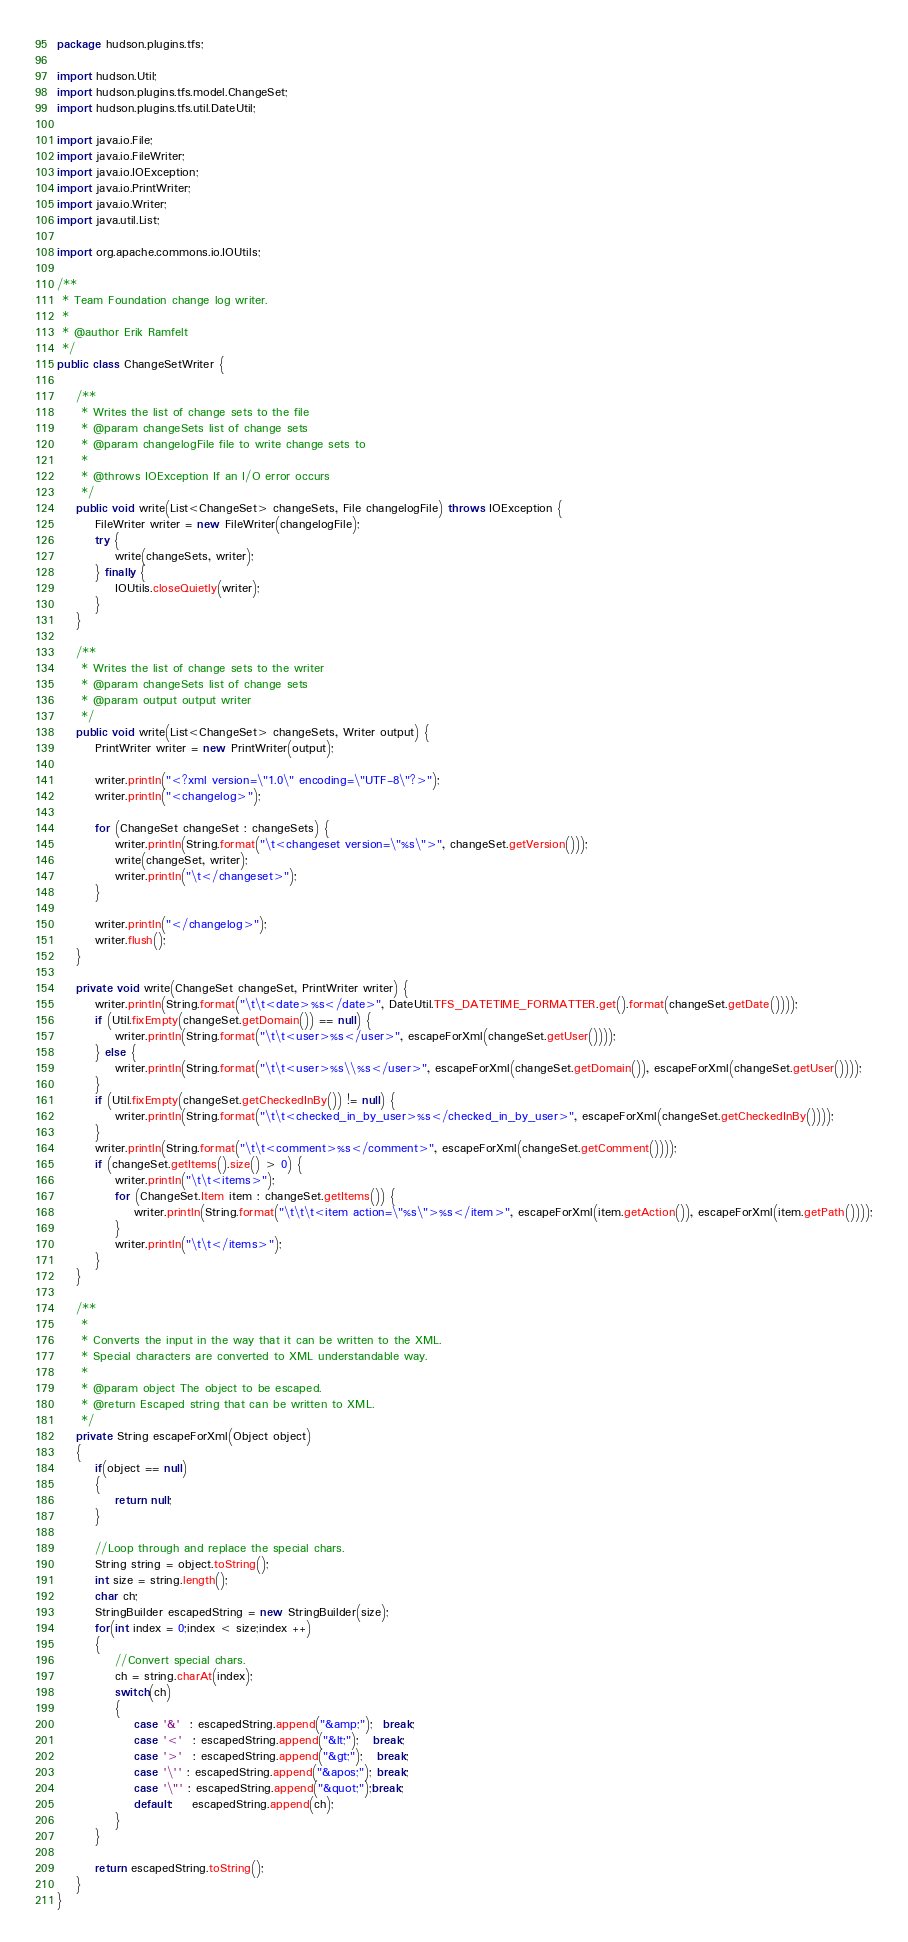Convert code to text. <code><loc_0><loc_0><loc_500><loc_500><_Java_>package hudson.plugins.tfs;

import hudson.Util;
import hudson.plugins.tfs.model.ChangeSet;
import hudson.plugins.tfs.util.DateUtil;

import java.io.File;
import java.io.FileWriter;
import java.io.IOException;
import java.io.PrintWriter;
import java.io.Writer;
import java.util.List;

import org.apache.commons.io.IOUtils;

/**
 * Team Foundation change log writer.
 * 
 * @author Erik Ramfelt
 */
public class ChangeSetWriter {

    /**
     * Writes the list of change sets to the file
     * @param changeSets list of change sets
     * @param changelogFile file to write change sets to
     *
     * @throws IOException If an I/O error occurs
     */
    public void write(List<ChangeSet> changeSets, File changelogFile) throws IOException {
        FileWriter writer = new FileWriter(changelogFile);
        try {
            write(changeSets, writer);
        } finally {
            IOUtils.closeQuietly(writer);
        }
    }

    /**
     * Writes the list of change sets to the writer
     * @param changeSets list of change sets
     * @param output output writer
     */    
    public void write(List<ChangeSet> changeSets, Writer output) {
        PrintWriter writer = new PrintWriter(output);
        
        writer.println("<?xml version=\"1.0\" encoding=\"UTF-8\"?>");
        writer.println("<changelog>");
        
        for (ChangeSet changeSet : changeSets) {
            writer.println(String.format("\t<changeset version=\"%s\">", changeSet.getVersion()));
            write(changeSet, writer);
            writer.println("\t</changeset>");
        }
        
        writer.println("</changelog>");
        writer.flush();
    }

    private void write(ChangeSet changeSet, PrintWriter writer) {
        writer.println(String.format("\t\t<date>%s</date>", DateUtil.TFS_DATETIME_FORMATTER.get().format(changeSet.getDate())));
        if (Util.fixEmpty(changeSet.getDomain()) == null) {
            writer.println(String.format("\t\t<user>%s</user>", escapeForXml(changeSet.getUser())));
        } else {
            writer.println(String.format("\t\t<user>%s\\%s</user>", escapeForXml(changeSet.getDomain()), escapeForXml(changeSet.getUser())));
        }
        if (Util.fixEmpty(changeSet.getCheckedInBy()) != null) {
            writer.println(String.format("\t\t<checked_in_by_user>%s</checked_in_by_user>", escapeForXml(changeSet.getCheckedInBy())));
        }
        writer.println(String.format("\t\t<comment>%s</comment>", escapeForXml(changeSet.getComment())));
        if (changeSet.getItems().size() > 0) {
            writer.println("\t\t<items>");
            for (ChangeSet.Item item : changeSet.getItems()) {
                writer.println(String.format("\t\t\t<item action=\"%s\">%s</item>", escapeForXml(item.getAction()), escapeForXml(item.getPath())));
            }
            writer.println("\t\t</items>");
        }
    }

    /**
     * 
     * Converts the input in the way that it can be written to the XML.
     * Special characters are converted to XML understandable way.
     * 
     * @param object The object to be escaped.
     * @return Escaped string that can be written to XML.
     */
    private String escapeForXml(Object object)
    {
        if(object == null)
        {
            return null;
        }

        //Loop through and replace the special chars.
        String string = object.toString();
        int size = string.length();
        char ch;
        StringBuilder escapedString = new StringBuilder(size);
        for(int index = 0;index < size;index ++)
        {
            //Convert special chars.
            ch = string.charAt(index);
            switch(ch)
            {
                case '&'  : escapedString.append("&amp;");  break;
                case '<'  : escapedString.append("&lt;");   break;
                case '>'  : escapedString.append("&gt;");   break;
                case '\'' : escapedString.append("&apos;"); break;
                case '\"' : escapedString.append("&quot;");break;
                default:    escapedString.append(ch);
            }
        }

        return escapedString.toString();
    }
}
</code> 